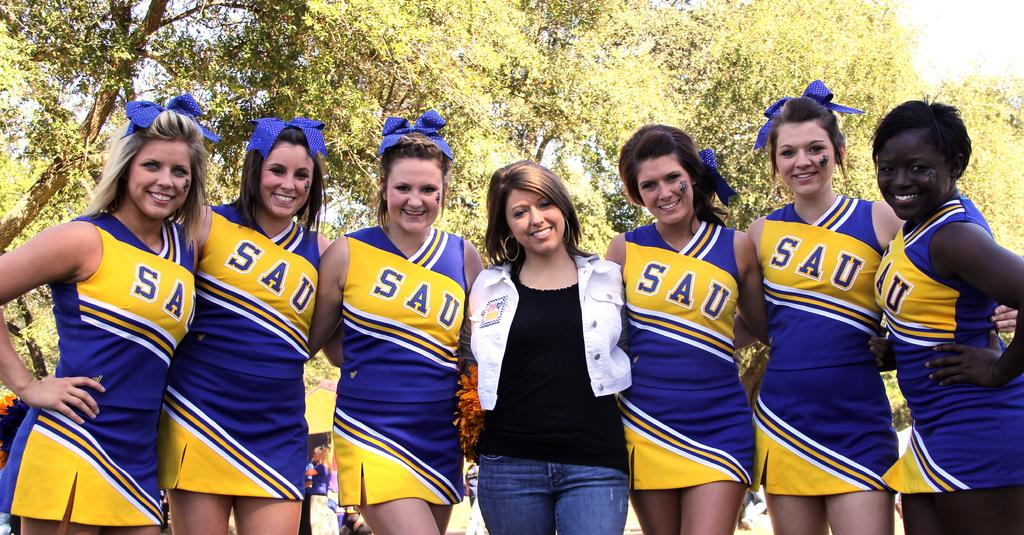<image>
Render a clear and concise summary of the photo. woman in white jacket surrounded by 6 SAU cheerleaders 